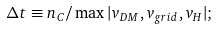Convert formula to latex. <formula><loc_0><loc_0><loc_500><loc_500>\Delta t \equiv n _ { C } / \max | v _ { D M } , v _ { g r i d } , v _ { H } | ;</formula> 